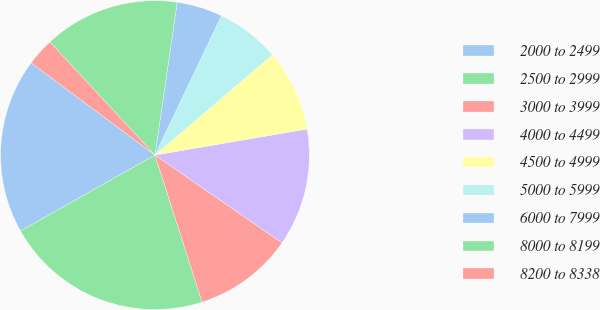<chart> <loc_0><loc_0><loc_500><loc_500><pie_chart><fcel>2000 to 2499<fcel>2500 to 2999<fcel>3000 to 3999<fcel>4000 to 4499<fcel>4500 to 4999<fcel>5000 to 5999<fcel>6000 to 7999<fcel>8000 to 8199<fcel>8200 to 8338<nl><fcel>18.37%<fcel>21.75%<fcel>10.44%<fcel>12.32%<fcel>8.55%<fcel>6.67%<fcel>4.78%<fcel>14.21%<fcel>2.9%<nl></chart> 